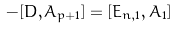Convert formula to latex. <formula><loc_0><loc_0><loc_500><loc_500>- [ D , A _ { p + 1 } ] = [ E _ { n , 1 } , A _ { 1 } ]</formula> 